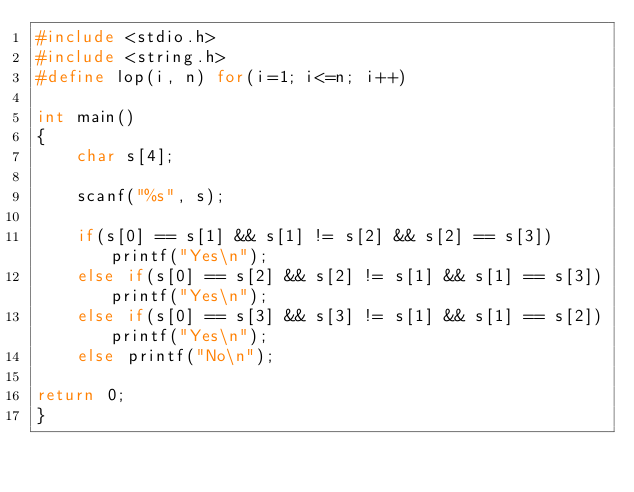<code> <loc_0><loc_0><loc_500><loc_500><_C_>#include <stdio.h>
#include <string.h>
#define lop(i, n) for(i=1; i<=n; i++)

int main()
{
	char s[4];
	
	scanf("%s", s);
	
	if(s[0] == s[1] && s[1] != s[2] && s[2] == s[3])printf("Yes\n");
	else if(s[0] == s[2] && s[2] != s[1] && s[1] == s[3])printf("Yes\n");
	else if(s[0] == s[3] && s[3] != s[1] && s[1] == s[2])printf("Yes\n");
	else printf("No\n");
	
return 0;
}</code> 